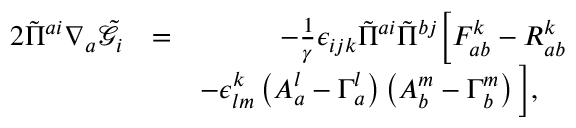<formula> <loc_0><loc_0><loc_500><loc_500>\begin{array} { r l r } { 2 \tilde { \Pi } ^ { a i } \nabla _ { a } \tilde { \mathcal { G } } _ { i } } & { = } & { - \frac { 1 } { \gamma } \epsilon _ { i j k } \tilde { \Pi } ^ { a i } \tilde { \Pi } ^ { b j } \left [ F _ { a b } ^ { k } - R _ { a b } ^ { k } } \\ & { - \epsilon ^ { k } _ { l m } \left ( A _ { a } ^ { l } - \Gamma _ { a } ^ { l } \right ) \left ( A _ { b } ^ { m } - \Gamma _ { b } ^ { m } \right ) \right ] , \quad } \end{array}</formula> 